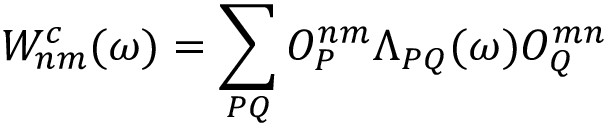<formula> <loc_0><loc_0><loc_500><loc_500>W _ { n m } ^ { c } ( \omega ) = \sum _ { P Q } O _ { P } ^ { n m } \Lambda _ { P Q } ( \omega ) O _ { Q } ^ { m n }</formula> 